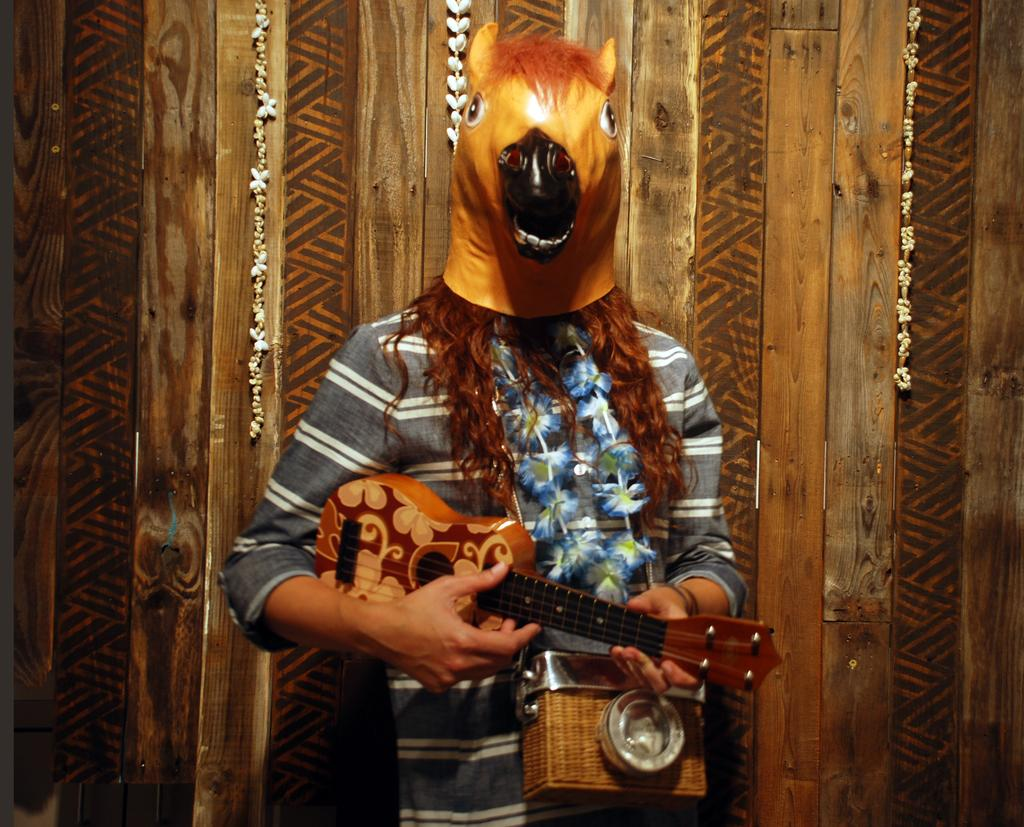Who is present in the image? There is a woman in the image. What is the woman wearing on her face? The woman is wearing a mask. What is the woman wearing around her neck? The woman is wearing a garland. What is the woman holding in her hands? The woman is holding a guitar and a camera. What can be seen in the background of the image? There is a wooden wall in the background of the image, and there are hangings on the wooden wall. What is the weather like in the image? The provided facts do not mention the weather, so we cannot determine the weather from the image. How many boys are present in the image? There are no boys present in the image; it features a woman. 